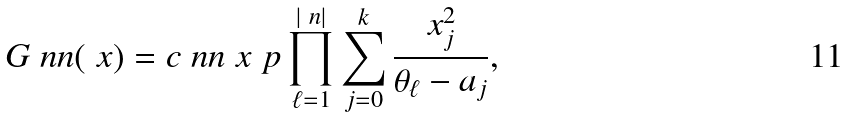Convert formula to latex. <formula><loc_0><loc_0><loc_500><loc_500>G _ { \ } n n ( \ x ) = c _ { \ } n n \ x ^ { \ } p \prod _ { \ell = 1 } ^ { | \ n | } \sum _ { j = 0 } ^ { k } \frac { x _ { j } ^ { 2 } } { \theta _ { \ell } - a _ { j } } ,</formula> 